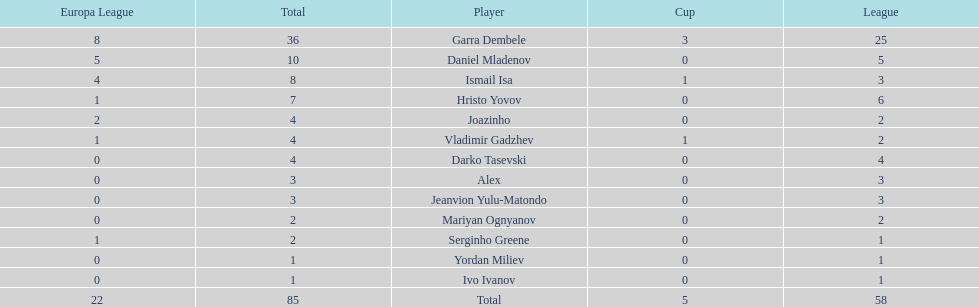Which players have at least 4 in the europa league? Garra Dembele, Daniel Mladenov, Ismail Isa. 